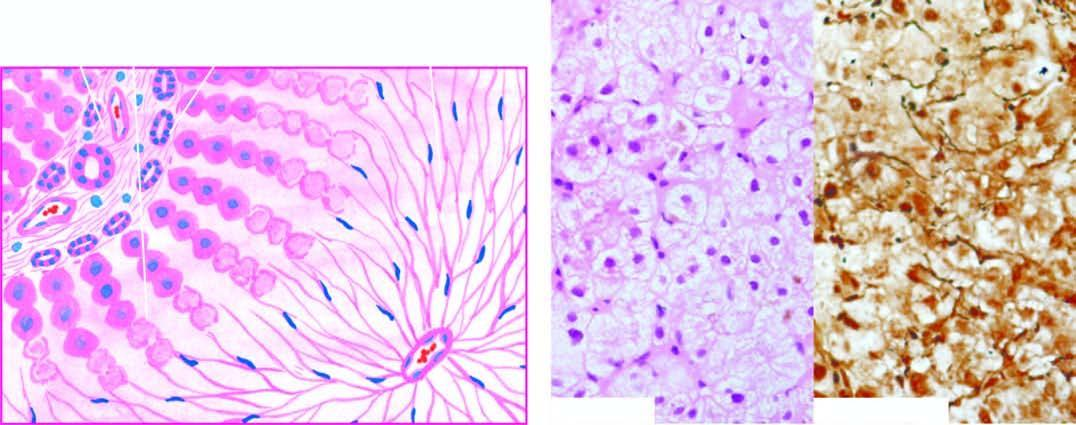s an asbestos body wiping out of liver lobules with only collapsed reticulin framework left out in their place, high lighted by reticulin stain right photomicrograph?
Answer the question using a single word or phrase. No 